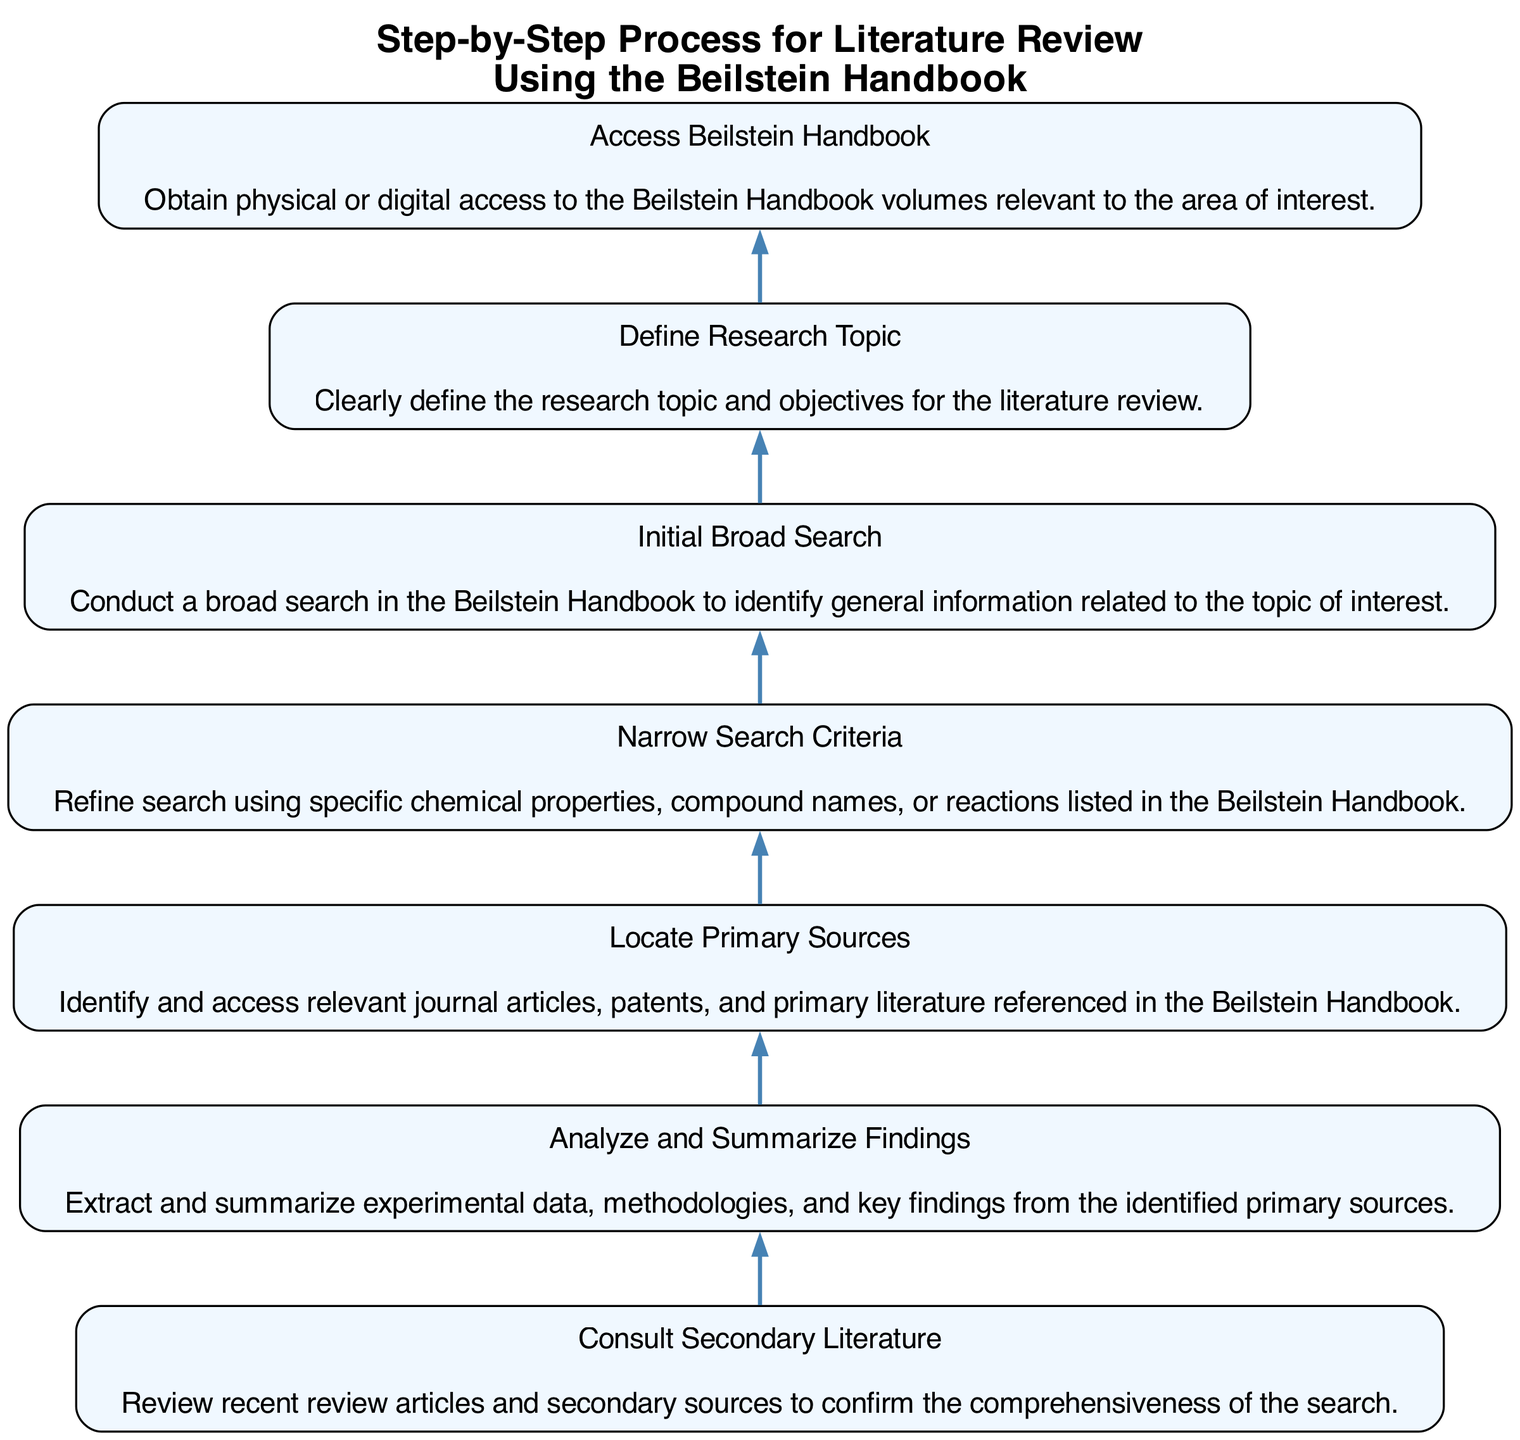What is the first step in the literature review process? The first step listed in the diagram is "Access Beilstein Handbook." It appears at the bottom of the flow chart, indicating it is the starting point of the process.
Answer: Access Beilstein Handbook How many steps are outlined in the process? The diagram outlines a total of seven steps. Each step is represented as a node in the flow chart, which can be counted.
Answer: Seven Which step follows "Narrow Search Criteria"? The step that follows "Narrow Search Criteria" is "Locate Primary Sources." By reviewing the flow from the position of "Narrow Search Criteria," we can identify the immediate next step.
Answer: Locate Primary Sources What is the last step of the literature review process? The last step in the flow chart is "Analyze and Summarize Findings." It is positioned at the top of the flow, indicating the completion of the process.
Answer: Analyze and Summarize Findings What is the relationship between "Define Research Topic" and "Initial Broad Search"? "Define Research Topic" precedes "Initial Broad Search" in the flowchart. This indicates that defining the research topic is a prerequisite for conducting the initial broad search.
Answer: Precedes In which step do you locate primary sources? You locate primary sources in the "Locate Primary Sources" step. This step specifically refers to identifying and accessing relevant literature mentioned in the Beilstein Handbook.
Answer: Locate Primary Sources How does the diagram suggest refining search criteria? The diagram suggests refining search criteria in the step titled "Narrow Search Criteria," which comes after the initial broad search, indicating the progression to a more focused search.
Answer: Narrow Search Criteria Which step connects "Access Beilstein Handbook" to "Define Research Topic"? The step that connects "Access Beilstein Handbook" to "Define Research Topic" is "Initial Broad Search." This shows the flow necessary to define the topic after accessing the Beilstein Handbook.
Answer: Initial Broad Search 